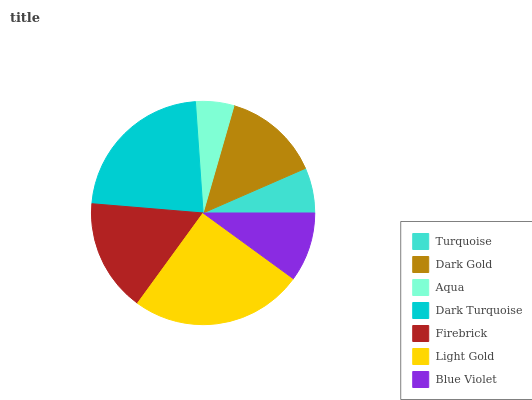Is Aqua the minimum?
Answer yes or no. Yes. Is Light Gold the maximum?
Answer yes or no. Yes. Is Dark Gold the minimum?
Answer yes or no. No. Is Dark Gold the maximum?
Answer yes or no. No. Is Dark Gold greater than Turquoise?
Answer yes or no. Yes. Is Turquoise less than Dark Gold?
Answer yes or no. Yes. Is Turquoise greater than Dark Gold?
Answer yes or no. No. Is Dark Gold less than Turquoise?
Answer yes or no. No. Is Dark Gold the high median?
Answer yes or no. Yes. Is Dark Gold the low median?
Answer yes or no. Yes. Is Light Gold the high median?
Answer yes or no. No. Is Blue Violet the low median?
Answer yes or no. No. 